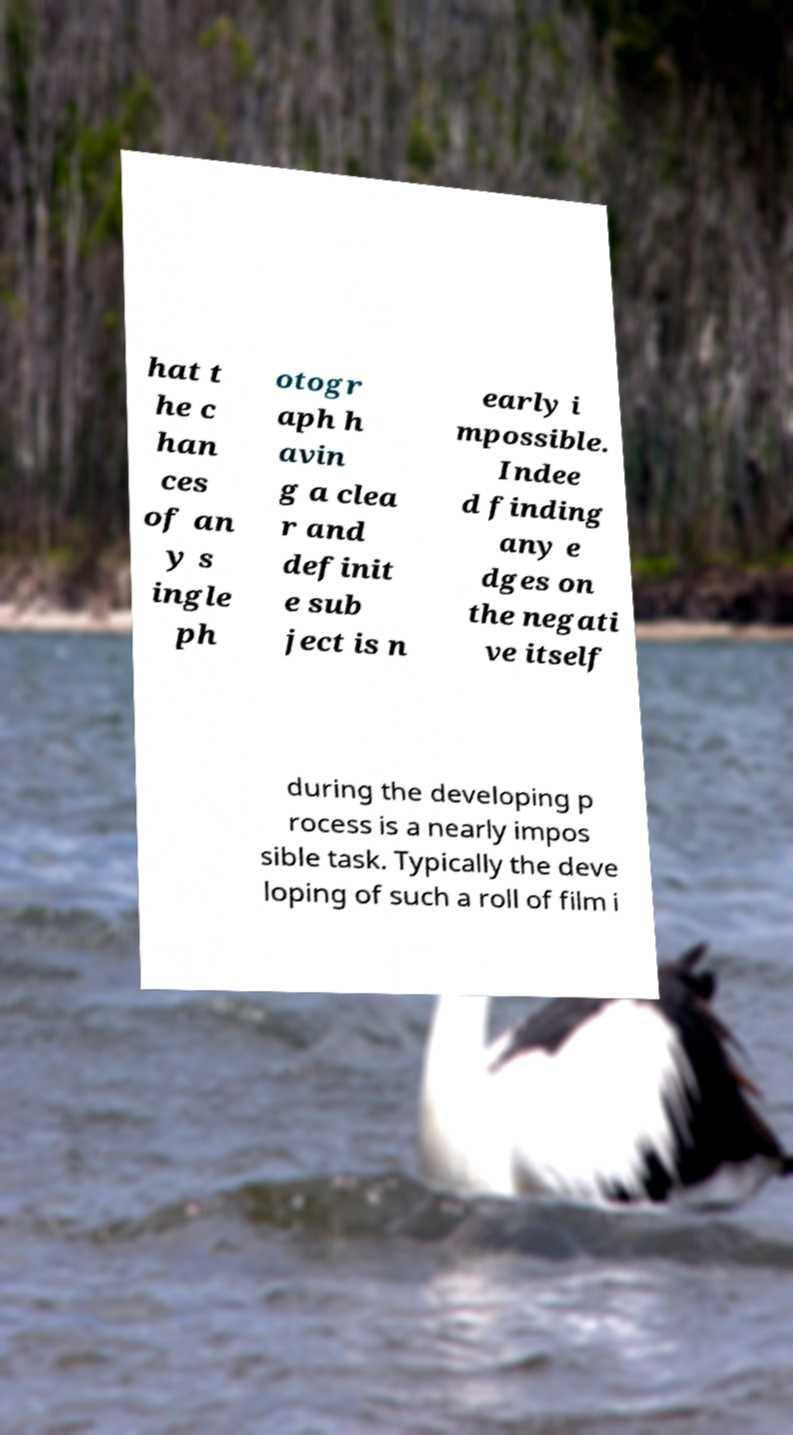Could you extract and type out the text from this image? hat t he c han ces of an y s ingle ph otogr aph h avin g a clea r and definit e sub ject is n early i mpossible. Indee d finding any e dges on the negati ve itself during the developing p rocess is a nearly impos sible task. Typically the deve loping of such a roll of film i 